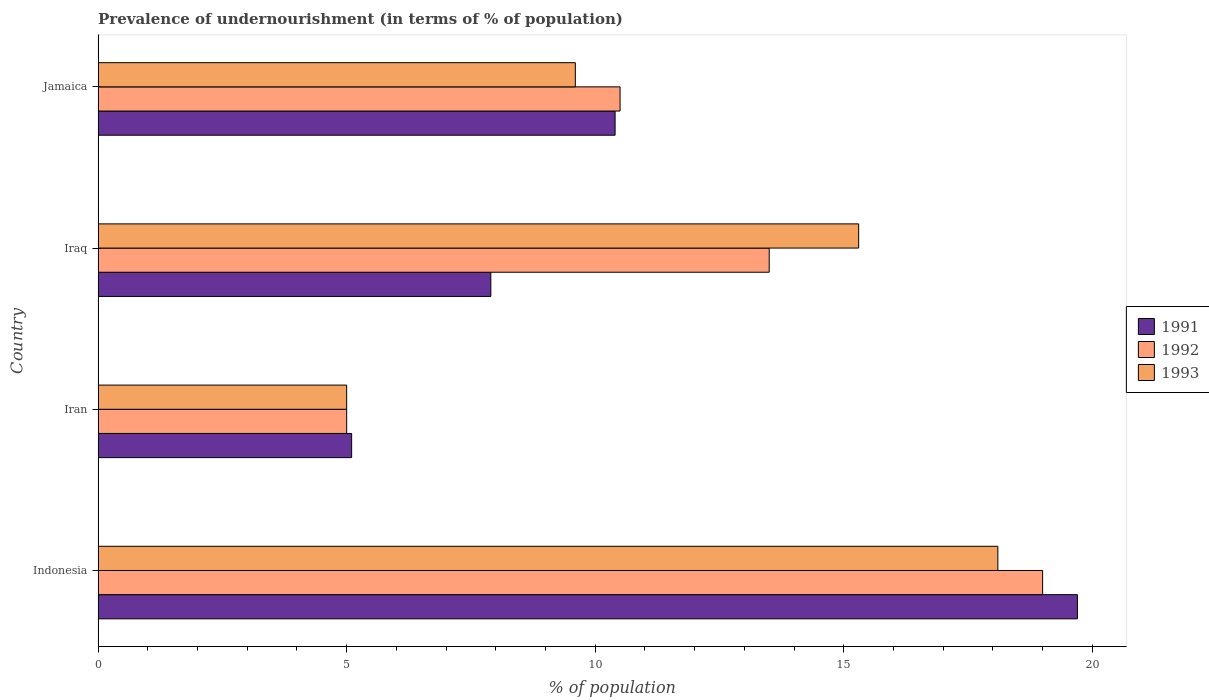How many different coloured bars are there?
Offer a very short reply. 3. How many groups of bars are there?
Offer a terse response. 4. How many bars are there on the 1st tick from the top?
Provide a succinct answer. 3. How many bars are there on the 1st tick from the bottom?
Your answer should be compact. 3. In how many cases, is the number of bars for a given country not equal to the number of legend labels?
Offer a very short reply. 0. What is the percentage of undernourished population in 1993 in Jamaica?
Ensure brevity in your answer.  9.6. Across all countries, what is the maximum percentage of undernourished population in 1993?
Your answer should be compact. 18.1. Across all countries, what is the minimum percentage of undernourished population in 1991?
Ensure brevity in your answer.  5.1. In which country was the percentage of undernourished population in 1991 maximum?
Provide a short and direct response. Indonesia. In which country was the percentage of undernourished population in 1991 minimum?
Offer a terse response. Iran. What is the total percentage of undernourished population in 1991 in the graph?
Provide a succinct answer. 43.1. What is the difference between the percentage of undernourished population in 1993 in Indonesia and that in Iraq?
Keep it short and to the point. 2.8. What is the average percentage of undernourished population in 1992 per country?
Ensure brevity in your answer.  12. What is the difference between the percentage of undernourished population in 1992 and percentage of undernourished population in 1991 in Jamaica?
Keep it short and to the point. 0.1. What is the ratio of the percentage of undernourished population in 1993 in Iraq to that in Jamaica?
Make the answer very short. 1.59. Is the difference between the percentage of undernourished population in 1992 in Indonesia and Iran greater than the difference between the percentage of undernourished population in 1991 in Indonesia and Iran?
Your answer should be very brief. No. What does the 3rd bar from the bottom in Iran represents?
Ensure brevity in your answer.  1993. Is it the case that in every country, the sum of the percentage of undernourished population in 1993 and percentage of undernourished population in 1992 is greater than the percentage of undernourished population in 1991?
Offer a terse response. Yes. Are all the bars in the graph horizontal?
Provide a short and direct response. Yes. How many countries are there in the graph?
Offer a very short reply. 4. What is the difference between two consecutive major ticks on the X-axis?
Your response must be concise. 5. Are the values on the major ticks of X-axis written in scientific E-notation?
Your response must be concise. No. How many legend labels are there?
Give a very brief answer. 3. How are the legend labels stacked?
Make the answer very short. Vertical. What is the title of the graph?
Offer a very short reply. Prevalence of undernourishment (in terms of % of population). Does "1989" appear as one of the legend labels in the graph?
Make the answer very short. No. What is the label or title of the X-axis?
Your answer should be very brief. % of population. What is the % of population in 1991 in Indonesia?
Give a very brief answer. 19.7. What is the % of population of 1993 in Indonesia?
Offer a terse response. 18.1. What is the % of population of 1991 in Iran?
Your answer should be very brief. 5.1. What is the % of population of 1991 in Iraq?
Ensure brevity in your answer.  7.9. Across all countries, what is the maximum % of population in 1991?
Offer a terse response. 19.7. Across all countries, what is the minimum % of population in 1992?
Ensure brevity in your answer.  5. What is the total % of population in 1991 in the graph?
Make the answer very short. 43.1. What is the total % of population in 1993 in the graph?
Keep it short and to the point. 48. What is the difference between the % of population in 1993 in Indonesia and that in Iran?
Your answer should be compact. 13.1. What is the difference between the % of population of 1992 in Indonesia and that in Iraq?
Your answer should be compact. 5.5. What is the difference between the % of population in 1993 in Indonesia and that in Iraq?
Offer a terse response. 2.8. What is the difference between the % of population of 1993 in Indonesia and that in Jamaica?
Your answer should be compact. 8.5. What is the difference between the % of population in 1993 in Iran and that in Iraq?
Keep it short and to the point. -10.3. What is the difference between the % of population of 1993 in Iran and that in Jamaica?
Offer a terse response. -4.6. What is the difference between the % of population of 1992 in Iraq and that in Jamaica?
Your response must be concise. 3. What is the difference between the % of population in 1991 in Indonesia and the % of population in 1992 in Iran?
Your answer should be very brief. 14.7. What is the difference between the % of population of 1991 in Indonesia and the % of population of 1993 in Iran?
Provide a succinct answer. 14.7. What is the difference between the % of population in 1992 in Indonesia and the % of population in 1993 in Iran?
Your answer should be compact. 14. What is the difference between the % of population in 1991 in Indonesia and the % of population in 1992 in Iraq?
Ensure brevity in your answer.  6.2. What is the difference between the % of population of 1991 in Indonesia and the % of population of 1993 in Jamaica?
Your answer should be compact. 10.1. What is the difference between the % of population in 1992 in Indonesia and the % of population in 1993 in Jamaica?
Make the answer very short. 9.4. What is the difference between the % of population in 1991 in Iran and the % of population in 1992 in Iraq?
Offer a very short reply. -8.4. What is the difference between the % of population of 1991 in Iran and the % of population of 1993 in Iraq?
Your response must be concise. -10.2. What is the difference between the % of population of 1992 in Iran and the % of population of 1993 in Iraq?
Keep it short and to the point. -10.3. What is the difference between the % of population in 1992 in Iran and the % of population in 1993 in Jamaica?
Your answer should be compact. -4.6. What is the difference between the % of population of 1991 in Iraq and the % of population of 1992 in Jamaica?
Ensure brevity in your answer.  -2.6. What is the difference between the % of population of 1992 in Iraq and the % of population of 1993 in Jamaica?
Offer a very short reply. 3.9. What is the average % of population in 1991 per country?
Provide a succinct answer. 10.78. What is the average % of population in 1992 per country?
Give a very brief answer. 12. What is the average % of population in 1993 per country?
Your response must be concise. 12. What is the difference between the % of population of 1991 and % of population of 1992 in Indonesia?
Keep it short and to the point. 0.7. What is the difference between the % of population in 1991 and % of population in 1992 in Iran?
Your response must be concise. 0.1. What is the difference between the % of population of 1991 and % of population of 1993 in Iran?
Your answer should be compact. 0.1. What is the difference between the % of population in 1991 and % of population in 1993 in Jamaica?
Your answer should be very brief. 0.8. What is the ratio of the % of population in 1991 in Indonesia to that in Iran?
Your response must be concise. 3.86. What is the ratio of the % of population in 1992 in Indonesia to that in Iran?
Make the answer very short. 3.8. What is the ratio of the % of population of 1993 in Indonesia to that in Iran?
Offer a very short reply. 3.62. What is the ratio of the % of population of 1991 in Indonesia to that in Iraq?
Provide a succinct answer. 2.49. What is the ratio of the % of population of 1992 in Indonesia to that in Iraq?
Offer a very short reply. 1.41. What is the ratio of the % of population of 1993 in Indonesia to that in Iraq?
Keep it short and to the point. 1.18. What is the ratio of the % of population in 1991 in Indonesia to that in Jamaica?
Offer a very short reply. 1.89. What is the ratio of the % of population of 1992 in Indonesia to that in Jamaica?
Make the answer very short. 1.81. What is the ratio of the % of population in 1993 in Indonesia to that in Jamaica?
Make the answer very short. 1.89. What is the ratio of the % of population in 1991 in Iran to that in Iraq?
Your response must be concise. 0.65. What is the ratio of the % of population in 1992 in Iran to that in Iraq?
Your response must be concise. 0.37. What is the ratio of the % of population of 1993 in Iran to that in Iraq?
Ensure brevity in your answer.  0.33. What is the ratio of the % of population in 1991 in Iran to that in Jamaica?
Ensure brevity in your answer.  0.49. What is the ratio of the % of population of 1992 in Iran to that in Jamaica?
Your answer should be very brief. 0.48. What is the ratio of the % of population in 1993 in Iran to that in Jamaica?
Give a very brief answer. 0.52. What is the ratio of the % of population in 1991 in Iraq to that in Jamaica?
Offer a very short reply. 0.76. What is the ratio of the % of population of 1992 in Iraq to that in Jamaica?
Your response must be concise. 1.29. What is the ratio of the % of population of 1993 in Iraq to that in Jamaica?
Provide a succinct answer. 1.59. What is the difference between the highest and the lowest % of population of 1993?
Offer a very short reply. 13.1. 